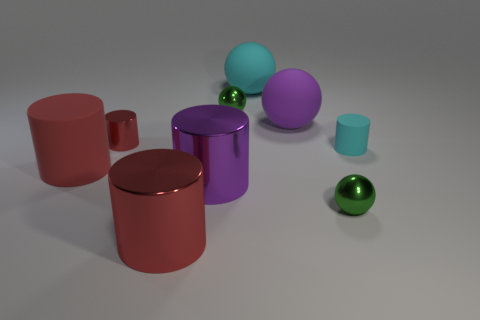How many red cylinders must be subtracted to get 1 red cylinders? 2 Subtract all cyan balls. How many balls are left? 3 Add 1 tiny red things. How many objects exist? 10 Subtract all cyan cylinders. How many cylinders are left? 4 Subtract all brown blocks. How many green balls are left? 2 Subtract all small green metal objects. Subtract all large purple things. How many objects are left? 5 Add 7 purple cylinders. How many purple cylinders are left? 8 Add 9 big cyan matte objects. How many big cyan matte objects exist? 10 Subtract 0 green blocks. How many objects are left? 9 Subtract all cylinders. How many objects are left? 4 